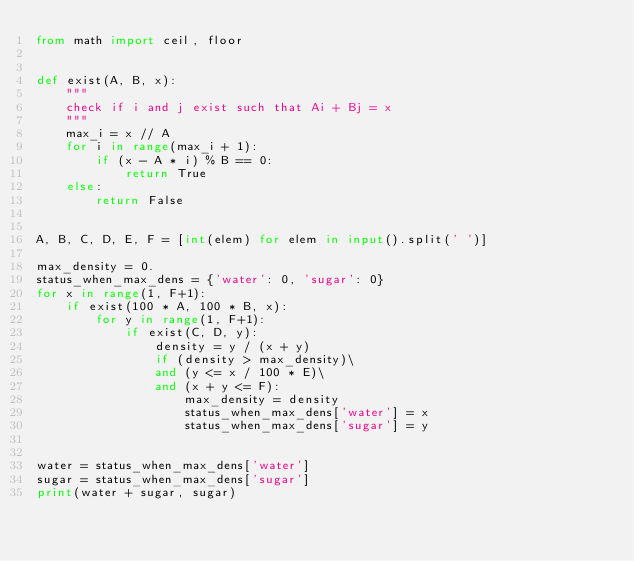<code> <loc_0><loc_0><loc_500><loc_500><_Python_>from math import ceil, floor


def exist(A, B, x):
    """
    check if i and j exist such that Ai + Bj = x
    """
    max_i = x // A
    for i in range(max_i + 1):
        if (x - A * i) % B == 0:
            return True
    else:
        return False


A, B, C, D, E, F = [int(elem) for elem in input().split(' ')]

max_density = 0.
status_when_max_dens = {'water': 0, 'sugar': 0}
for x in range(1, F+1):
    if exist(100 * A, 100 * B, x):
        for y in range(1, F+1):
            if exist(C, D, y):
                density = y / (x + y)
                if (density > max_density)\
                and (y <= x / 100 * E)\
                and (x + y <= F):
                    max_density = density
                    status_when_max_dens['water'] = x
                    status_when_max_dens['sugar'] = y


water = status_when_max_dens['water']
sugar = status_when_max_dens['sugar']
print(water + sugar, sugar)
</code> 